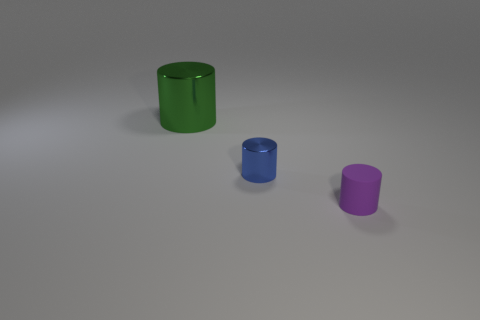How many tiny metal objects have the same shape as the large thing?
Ensure brevity in your answer.  1. What is the material of the green cylinder?
Ensure brevity in your answer.  Metal. How many things are either large brown metallic cylinders or shiny cylinders?
Provide a short and direct response. 2. There is a shiny cylinder that is in front of the large metal object; what is its size?
Make the answer very short. Small. How many other things are the same material as the blue thing?
Keep it short and to the point. 1. There is a shiny thing that is behind the tiny blue metallic object; is there a small purple rubber cylinder on the left side of it?
Your answer should be compact. No. Are there any other things that have the same shape as the blue shiny thing?
Give a very brief answer. Yes. What color is the other small object that is the same shape as the blue thing?
Keep it short and to the point. Purple. How big is the blue metallic thing?
Ensure brevity in your answer.  Small. Are there fewer purple matte things to the left of the big shiny cylinder than cubes?
Your response must be concise. No. 